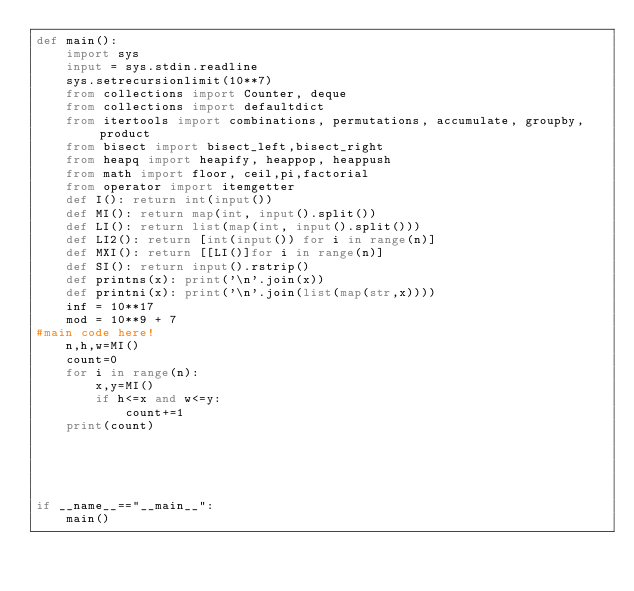Convert code to text. <code><loc_0><loc_0><loc_500><loc_500><_Python_>def main():
    import sys
    input = sys.stdin.readline
    sys.setrecursionlimit(10**7)
    from collections import Counter, deque
    from collections import defaultdict
    from itertools import combinations, permutations, accumulate, groupby, product
    from bisect import bisect_left,bisect_right
    from heapq import heapify, heappop, heappush
    from math import floor, ceil,pi,factorial
    from operator import itemgetter
    def I(): return int(input())
    def MI(): return map(int, input().split())
    def LI(): return list(map(int, input().split()))
    def LI2(): return [int(input()) for i in range(n)]
    def MXI(): return [[LI()]for i in range(n)]
    def SI(): return input().rstrip()
    def printns(x): print('\n'.join(x))
    def printni(x): print('\n'.join(list(map(str,x))))
    inf = 10**17
    mod = 10**9 + 7
#main code here!
    n,h,w=MI()
    count=0
    for i in range(n):
        x,y=MI()
        if h<=x and w<=y:
            count+=1
    print(count)
        
        
        
        
    
if __name__=="__main__":
    main()

</code> 